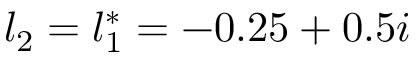<formula> <loc_0><loc_0><loc_500><loc_500>l _ { 2 } = l _ { 1 } ^ { * } = - 0 . 2 5 + 0 . 5 i</formula> 